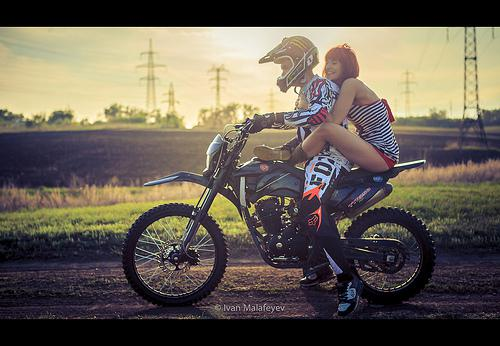Question: what are they riding?
Choices:
A. The bike.
B. A motorcycle.
C. A tandem bike.
D. A camel.
Answer with the letter. Answer: A Question: who is riding?
Choices:
A. People.
B. Children.
C. Men.
D. Women.
Answer with the letter. Answer: A Question: what is he wearing?
Choices:
A. Helmet.
B. Hat.
C. Sweatshirt.
D. Sunglasses.
Answer with the letter. Answer: A Question: what are they doing?
Choices:
A. Riding.
B. Walking.
C. Dancing.
D. Biking.
Answer with the letter. Answer: A 